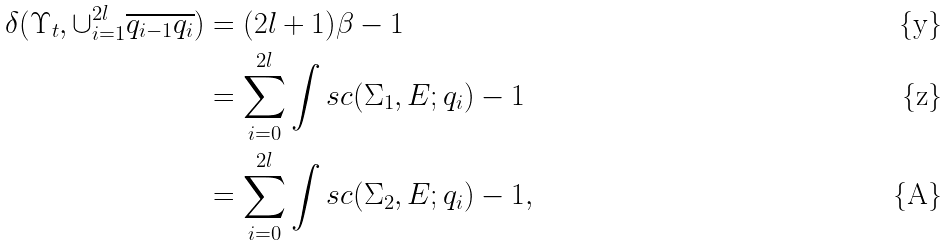<formula> <loc_0><loc_0><loc_500><loc_500>\delta ( \Upsilon _ { t } , \cup _ { i = 1 } ^ { 2 l } \overline { q _ { i - 1 } q _ { i } } ) & = ( 2 l + 1 ) \beta - 1 \\ & = \sum _ { i = 0 } ^ { 2 l } \int s c ( \Sigma _ { 1 } , E ; q _ { i } ) - 1 \\ & = \sum _ { i = 0 } ^ { 2 l } \int s c ( \Sigma _ { 2 } , E ; q _ { i } ) - 1 ,</formula> 